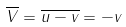<formula> <loc_0><loc_0><loc_500><loc_500>\overline { V } = \overline { { u } - { v } } = - { v }</formula> 